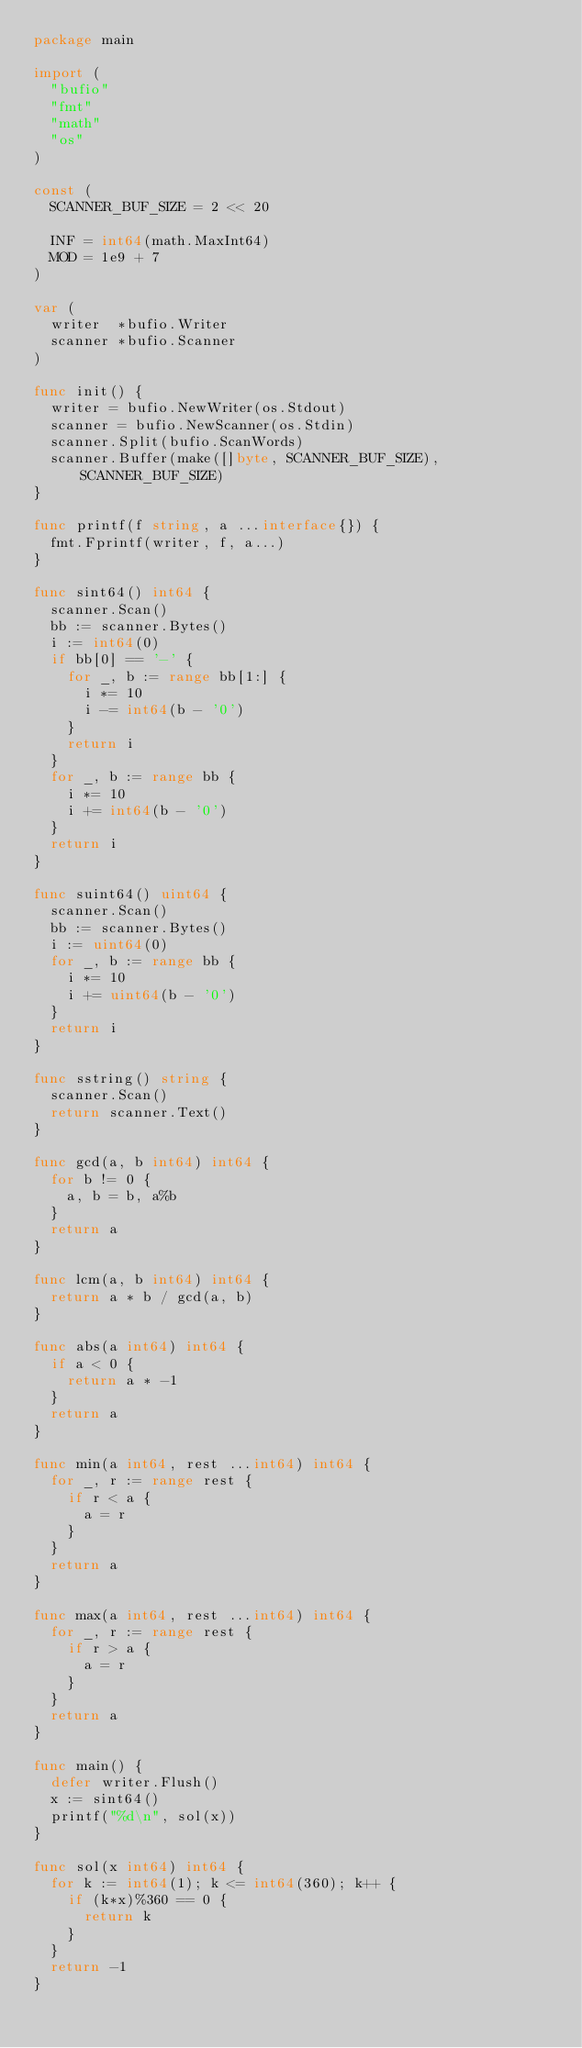<code> <loc_0><loc_0><loc_500><loc_500><_Go_>package main

import (
	"bufio"
	"fmt"
	"math"
	"os"
)

const (
	SCANNER_BUF_SIZE = 2 << 20

	INF = int64(math.MaxInt64)
	MOD = 1e9 + 7
)

var (
	writer  *bufio.Writer
	scanner *bufio.Scanner
)

func init() {
	writer = bufio.NewWriter(os.Stdout)
	scanner = bufio.NewScanner(os.Stdin)
	scanner.Split(bufio.ScanWords)
	scanner.Buffer(make([]byte, SCANNER_BUF_SIZE), SCANNER_BUF_SIZE)
}

func printf(f string, a ...interface{}) {
	fmt.Fprintf(writer, f, a...)
}

func sint64() int64 {
	scanner.Scan()
	bb := scanner.Bytes()
	i := int64(0)
	if bb[0] == '-' {
		for _, b := range bb[1:] {
			i *= 10
			i -= int64(b - '0')
		}
		return i
	}
	for _, b := range bb {
		i *= 10
		i += int64(b - '0')
	}
	return i
}

func suint64() uint64 {
	scanner.Scan()
	bb := scanner.Bytes()
	i := uint64(0)
	for _, b := range bb {
		i *= 10
		i += uint64(b - '0')
	}
	return i
}

func sstring() string {
	scanner.Scan()
	return scanner.Text()
}

func gcd(a, b int64) int64 {
	for b != 0 {
		a, b = b, a%b
	}
	return a
}

func lcm(a, b int64) int64 {
	return a * b / gcd(a, b)
}

func abs(a int64) int64 {
	if a < 0 {
		return a * -1
	}
	return a
}

func min(a int64, rest ...int64) int64 {
	for _, r := range rest {
		if r < a {
			a = r
		}
	}
	return a
}

func max(a int64, rest ...int64) int64 {
	for _, r := range rest {
		if r > a {
			a = r
		}
	}
	return a
}

func main() {
	defer writer.Flush()
	x := sint64()
	printf("%d\n", sol(x))
}

func sol(x int64) int64 {
	for k := int64(1); k <= int64(360); k++ {
		if (k*x)%360 == 0 {
			return k
		}
	}
	return -1
}
</code> 